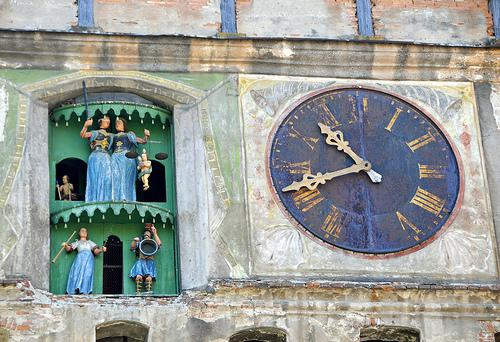Question: what time does the clock say?
Choices:
A. 2:21.
B. 5:19.
C. 12:11.
D. 10:42.
Answer with the letter. Answer: D Question: what color clothing are the statues wearing?
Choices:
A. Green.
B. Grey.
C. White.
D. Blue.
Answer with the letter. Answer: D Question: who is to the left of the clock?
Choices:
A. Paintings.
B. Statues.
C. Sculptures.
D. People.
Answer with the letter. Answer: B Question: where are the statues?
Choices:
A. To the left of the clock.
B. To the right of the clock.
C. Under the clock.
D. In front of the clock.
Answer with the letter. Answer: A Question: what is the clock tower made out of?
Choices:
A. Brick.
B. Cinder blocks.
C. Stone.
D. Wood.
Answer with the letter. Answer: C 